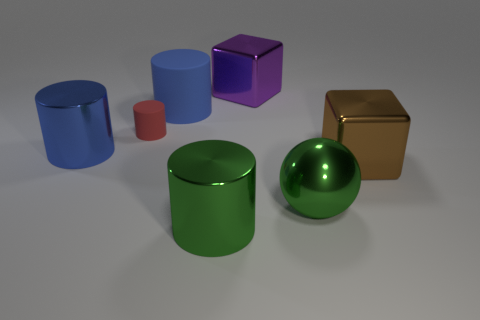Subtract all red cylinders. How many cylinders are left? 3 Subtract all purple cubes. How many cubes are left? 1 Add 1 blue objects. How many objects exist? 8 Add 4 blue objects. How many blue objects are left? 6 Add 1 red objects. How many red objects exist? 2 Subtract 0 red spheres. How many objects are left? 7 Subtract all cylinders. How many objects are left? 3 Subtract 1 cylinders. How many cylinders are left? 3 Subtract all gray blocks. Subtract all purple cylinders. How many blocks are left? 2 Subtract all purple blocks. How many red cylinders are left? 1 